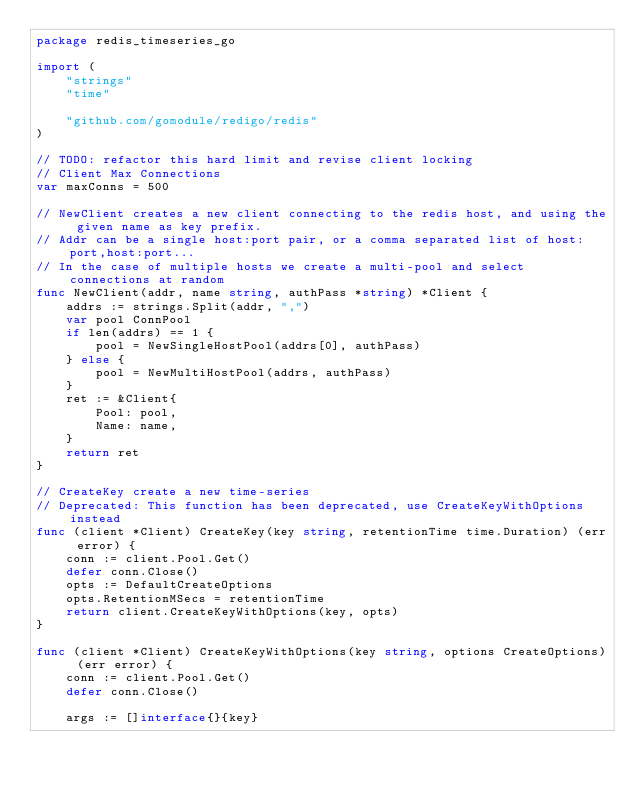<code> <loc_0><loc_0><loc_500><loc_500><_Go_>package redis_timeseries_go

import (
	"strings"
	"time"

	"github.com/gomodule/redigo/redis"
)

// TODO: refactor this hard limit and revise client locking
// Client Max Connections
var maxConns = 500

// NewClient creates a new client connecting to the redis host, and using the given name as key prefix.
// Addr can be a single host:port pair, or a comma separated list of host:port,host:port...
// In the case of multiple hosts we create a multi-pool and select connections at random
func NewClient(addr, name string, authPass *string) *Client {
	addrs := strings.Split(addr, ",")
	var pool ConnPool
	if len(addrs) == 1 {
		pool = NewSingleHostPool(addrs[0], authPass)
	} else {
		pool = NewMultiHostPool(addrs, authPass)
	}
	ret := &Client{
		Pool: pool,
		Name: name,
	}
	return ret
}

// CreateKey create a new time-series
// Deprecated: This function has been deprecated, use CreateKeyWithOptions instead
func (client *Client) CreateKey(key string, retentionTime time.Duration) (err error) {
	conn := client.Pool.Get()
	defer conn.Close()
	opts := DefaultCreateOptions
	opts.RetentionMSecs = retentionTime
	return client.CreateKeyWithOptions(key, opts)
}

func (client *Client) CreateKeyWithOptions(key string, options CreateOptions) (err error) {
	conn := client.Pool.Get()
	defer conn.Close()

	args := []interface{}{key}</code> 